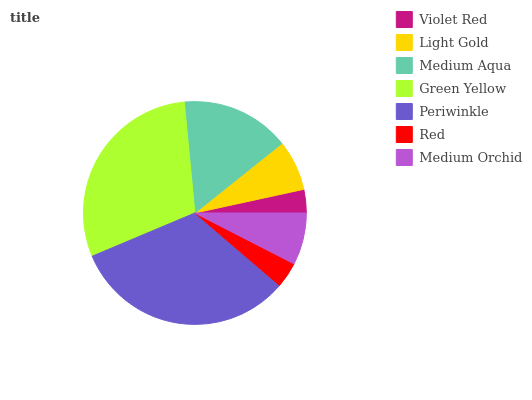Is Violet Red the minimum?
Answer yes or no. Yes. Is Periwinkle the maximum?
Answer yes or no. Yes. Is Light Gold the minimum?
Answer yes or no. No. Is Light Gold the maximum?
Answer yes or no. No. Is Light Gold greater than Violet Red?
Answer yes or no. Yes. Is Violet Red less than Light Gold?
Answer yes or no. Yes. Is Violet Red greater than Light Gold?
Answer yes or no. No. Is Light Gold less than Violet Red?
Answer yes or no. No. Is Medium Orchid the high median?
Answer yes or no. Yes. Is Medium Orchid the low median?
Answer yes or no. Yes. Is Red the high median?
Answer yes or no. No. Is Violet Red the low median?
Answer yes or no. No. 